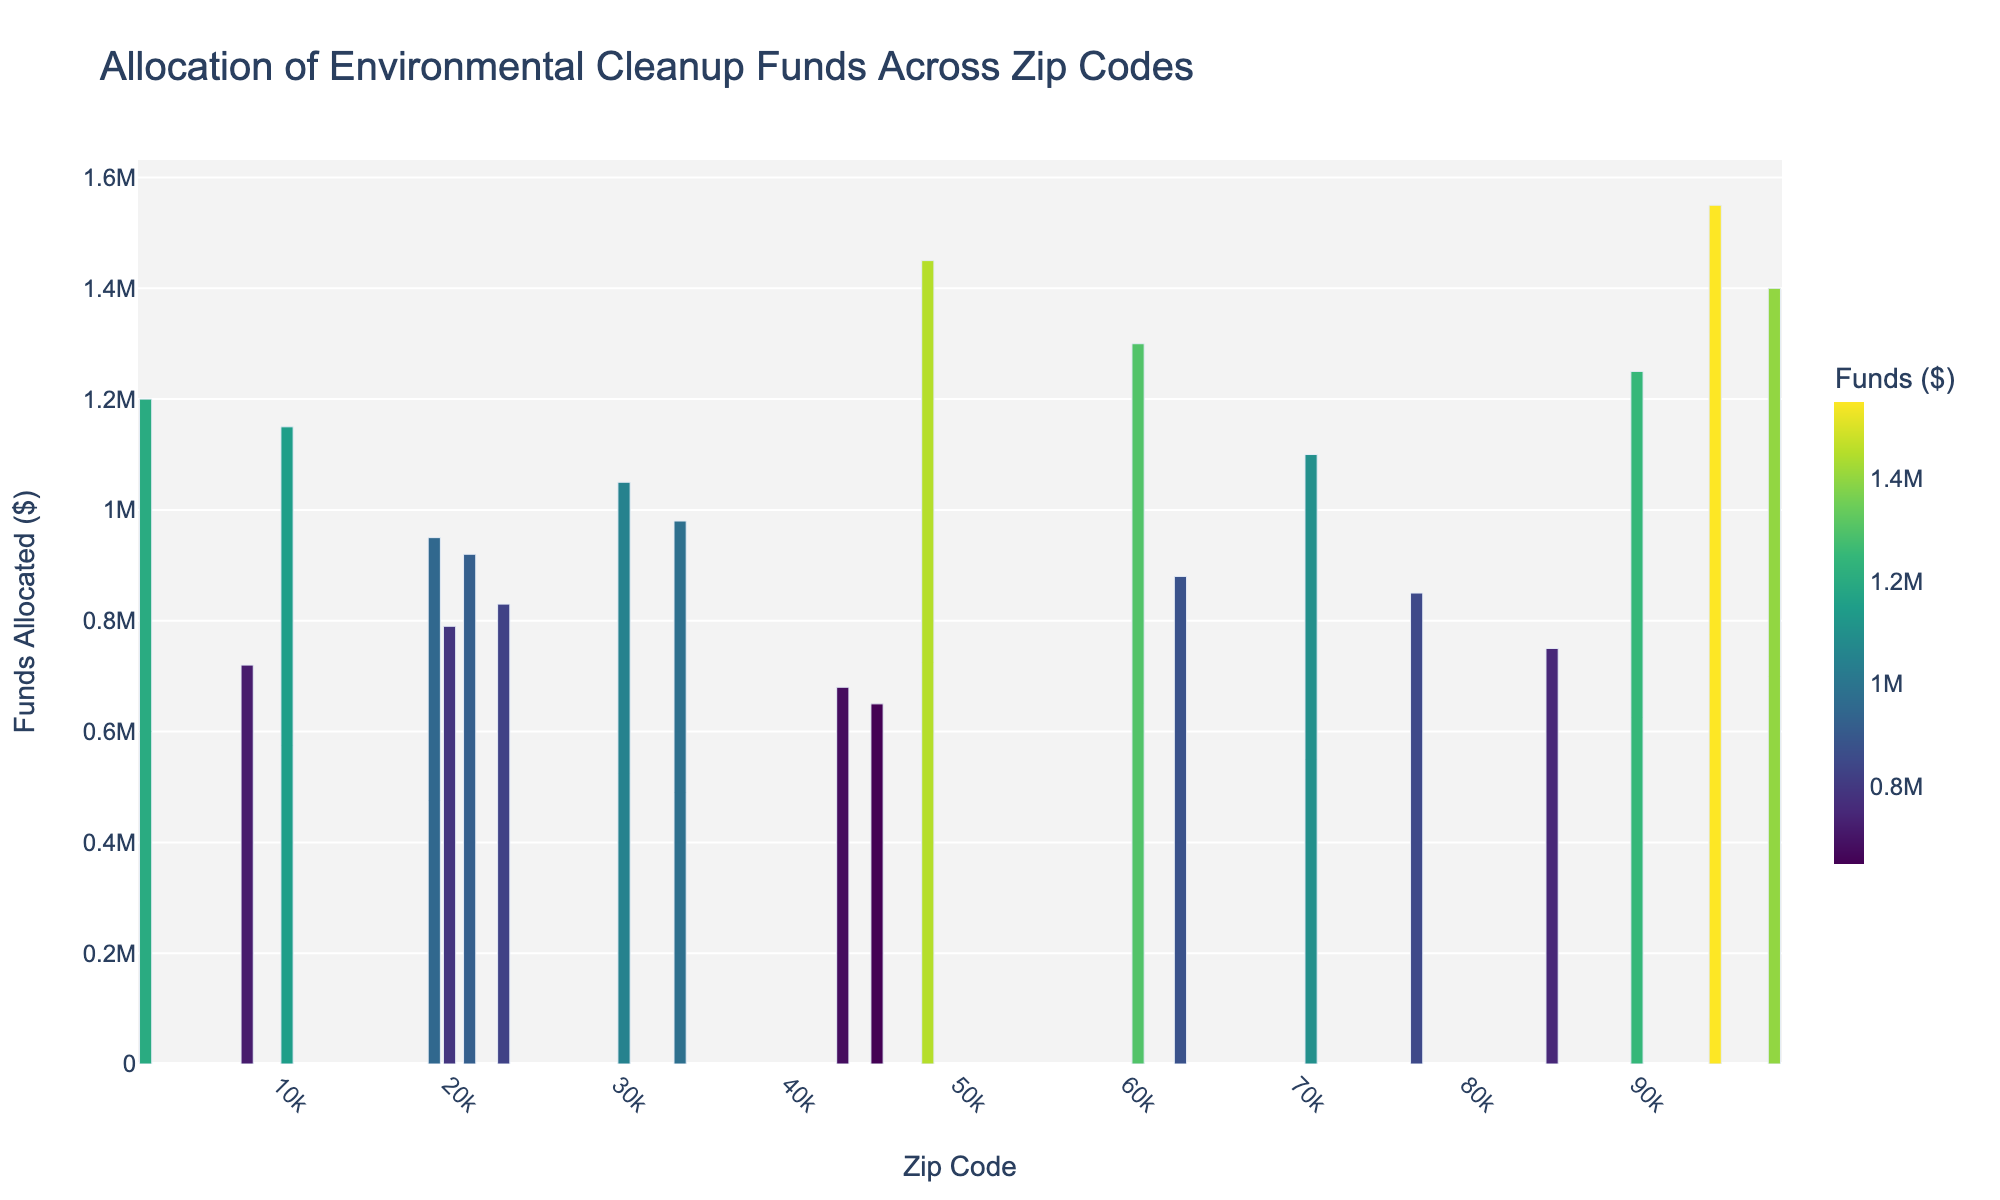which zip code received the highest cleanup funds? The zip code with the highest bar corresponds to the highest allocated cleanup funds.
Answer: 94621 which zip code received more cleanup funds, 90011 or 48217? Compare the heights of the bars for zip codes 90011 and 48217. The one with the taller bar received more funds.
Answer: 48217 what is the average cleanup funds allocated across the listed zip codes? Sum all the allocated funds and divide by the total number of zip codes. Calculation: (1250000 + 980000 + 1450000 + 1100000 + 850000 + 720000 + 1300000 + 950000 + 680000 + 1550000 + 790000 + 1050000 + 880000 + 1200000 + 750000 + 920000 + 650000 + 1400000 + 830000 + 1150000) / 20 = 10290000 / 20.
Answer: 1029000 which zip code received the least cleanup funds? The zip code with the shortest bar corresponds to the least allocated cleanup funds.
Answer: 45225 how much more cleanup funds did 60609 receive compared to 85009? Subtract the cleanup funds of zip code 85009 from that of 60609. Calculation: 1300000 - 750000.
Answer: 550000 which zip codes received cleanup funds greater than 1 million dollars? Identify the zip codes with bars surpassing the $1 million mark (bars extending above this point).
Answer: 90011, 48217, 60609, 94621, 19132, 30315, 02121, 10454 what is the total cleanup funds allocated to zip codes starting with '7'? Sum the cleanup funds for zip codes 77026 and 70805. Calculation: 850000 + 1100000.
Answer: 1950000 